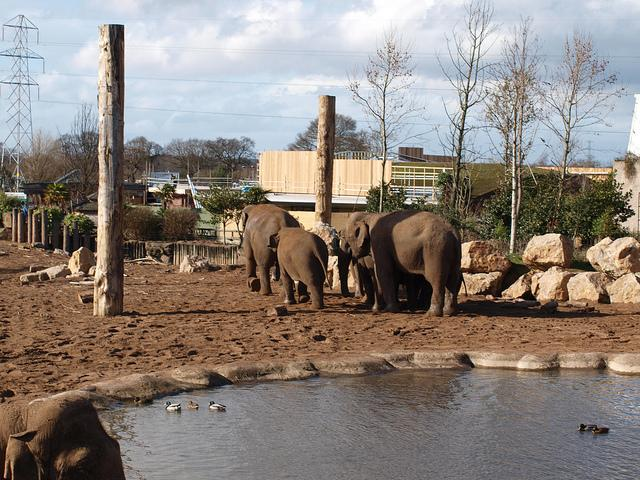What body of water is this? pond 